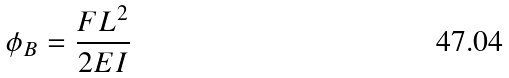Convert formula to latex. <formula><loc_0><loc_0><loc_500><loc_500>\phi _ { B } = \frac { F L ^ { 2 } } { 2 E I }</formula> 